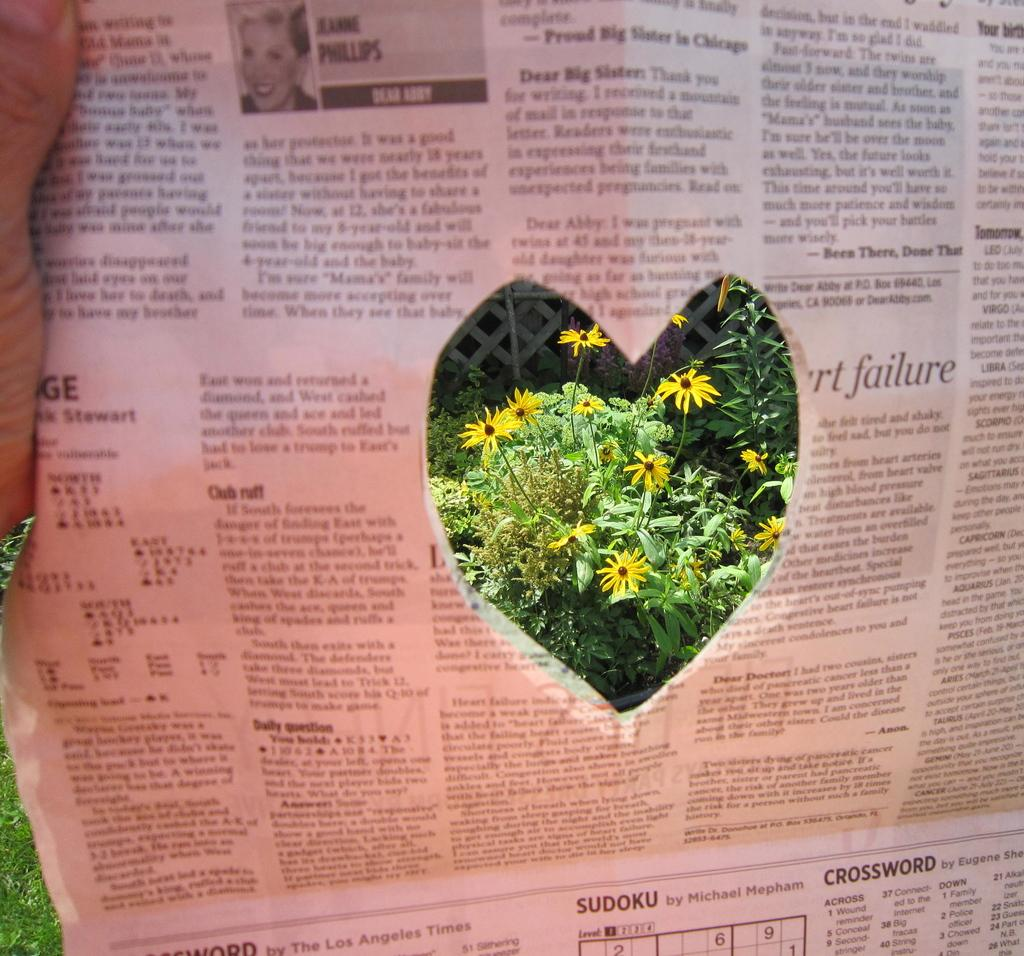What is the person in the image holding? The person is holding a newspaper. What feature of the newspaper is highlighted in the image? There is a heart-shaped section in the newspaper. What can be seen through the heart-shaped section? Flowers are visible through the heart-shaped section. How many boats are visible in the image? There are no boats present in the image. What type of fireman is shown in the image? There is no fireman present in the image. 